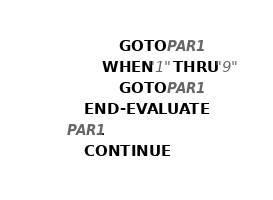Convert code to text. <code><loc_0><loc_0><loc_500><loc_500><_COBOL_>                   GO TO PAR1
               WHEN "1" THRU "9"
                   GO TO PAR1
           END-EVALUATE.
       PAR1.
           CONTINUE.</code> 